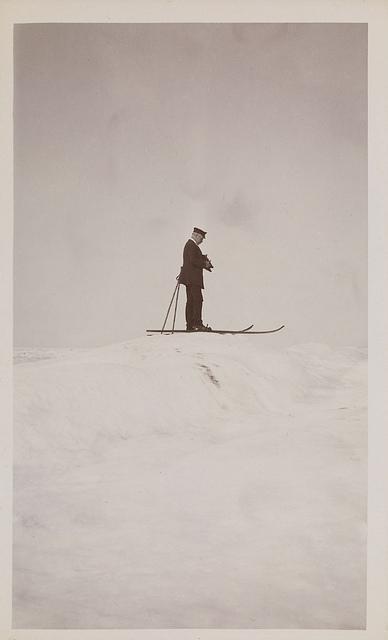How many ski poles do you see?
Give a very brief answer. 2. How many orange lights are on the back of the bus?
Give a very brief answer. 0. 